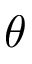<formula> <loc_0><loc_0><loc_500><loc_500>\theta</formula> 